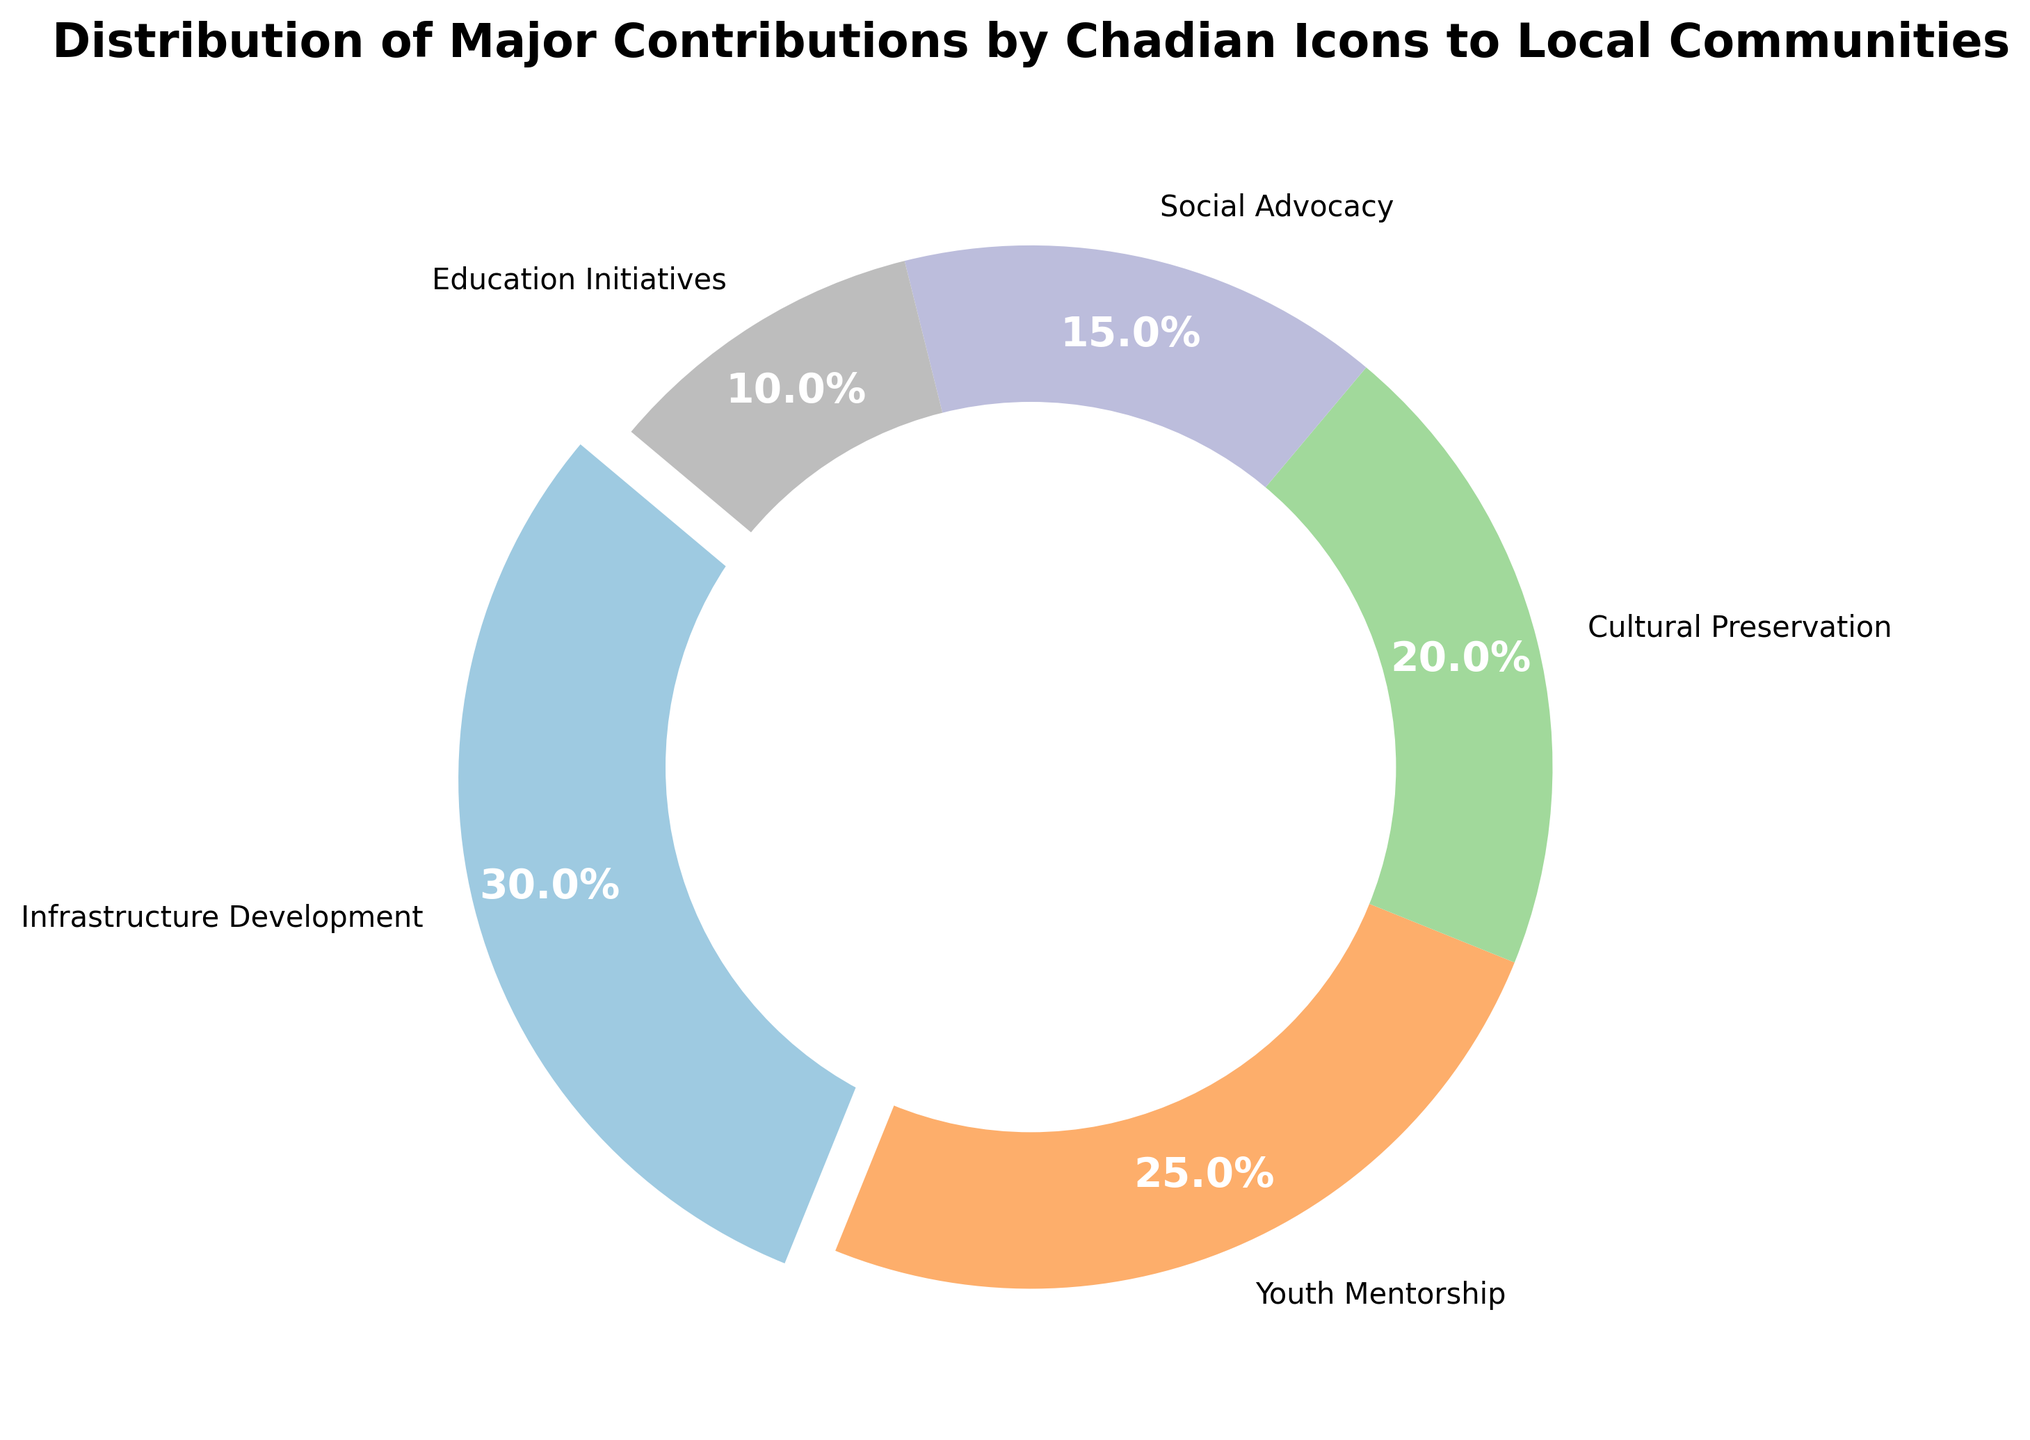What percentage of contributions are dedicated to infrastructure development? The figure shows that infrastructure development occupies the largest segment, and it has the percentage label directly on it.
Answer: 30% How much more percentage do Chadian icons contribute to youth mentorship compared to social advocacy? The pie chart shows that youth mentorship is 25% and social advocacy is 15%, so the difference can be calculated as 25% - 15%.
Answer: 10% Which contribution has the smallest percentage, and what is this percentage? The smallest segment in the pie chart represents Education Initiatives, as indicated by both the size and the percentage label next to it.
Answer: Education Initiatives, 10% If we add the percentages of cultural preservation and social advocacy, what is the total contribution percentage? From the pie chart, cultural preservation is 20% and social advocacy is 15%. Adding these gives 20% + 15%.
Answer: 35% What is the combined percentage of infrastructure development, youth mentorship, and education initiatives? Infrastructure development is 30%, youth mentorship is 25%, and education initiatives is 10%. Their combined percentage is 30% + 25% + 10%.
Answer: 65% Which contribution comes closest to representing a quarter of the total contributions and what is this percentage? A quarter of 100% is 25%. The chart shows that youth mentorship exactly represents 25%.
Answer: Youth Mentorship, 25% How does the contribution to infrastructure development compare visually to youth mentorship? The pie chart explodes the infrastructure development segment, making it more prominent. It is also larger than the youth mentorship segment.
Answer: Infrastructure development is larger and highlighted What colors are used to represent cultural preservation and social advocacy? Cultural preservation and social advocacy are adjacent on the pie chart, with cultural preservation represented by a specific color and social advocacy by another.
Answer: Cultural preservation is one color, social advocacy is another color 